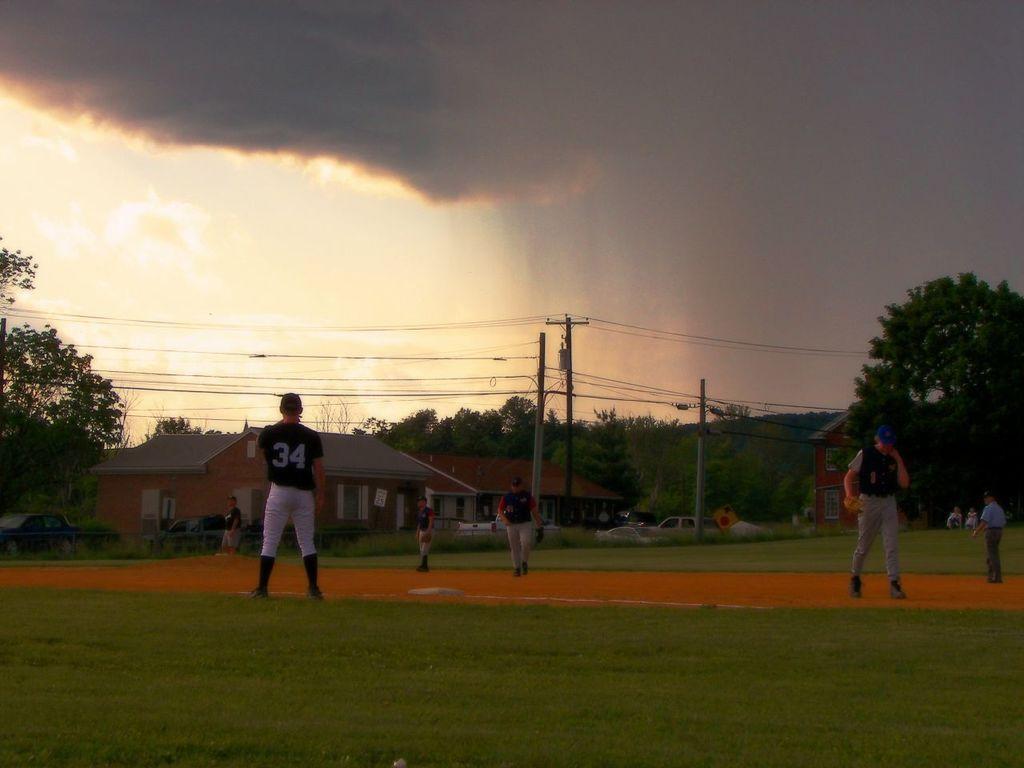Could you give a brief overview of what you see in this image? This picture might be taken inside a playground. In this image, we can see a few people are walking and few people are standing. On the right side, we can see some trees and houses. In the background, we can see a car, houses, trees, electrical pole, electrical wires. On the top, we can see a sky which is cloudy, at the bottom there is a grass and a land. 